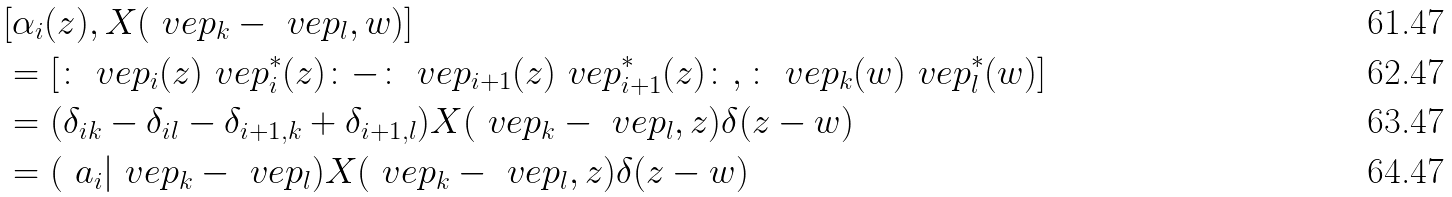<formula> <loc_0><loc_0><loc_500><loc_500>& [ \alpha _ { i } ( z ) , X ( \ v e p _ { k } - \ v e p _ { l } , w ) ] \\ & = [ \colon \ v e p _ { i } ( z ) \ v e p _ { i } ^ { * } ( z ) \colon - \colon \ v e p _ { i + 1 } ( z ) \ v e p _ { i + 1 } ^ { * } ( z ) \colon , \colon \ v e p _ { k } ( w ) \ v e p _ { l } ^ { * } ( w ) ] \\ & = ( \delta _ { i k } - \delta _ { i l } - \delta _ { i + 1 , k } + \delta _ { i + 1 , l } ) X ( \ v e p _ { k } - \ v e p _ { l } , z ) \delta ( z - w ) \\ & = ( \ a _ { i } | \ v e p _ { k } - \ v e p _ { l } ) X ( \ v e p _ { k } - \ v e p _ { l } , z ) \delta ( z - w )</formula> 